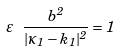Convert formula to latex. <formula><loc_0><loc_0><loc_500><loc_500>\varepsilon \ \frac { b ^ { 2 } } { | \kappa _ { 1 } - k _ { 1 } | ^ { 2 } } = 1</formula> 